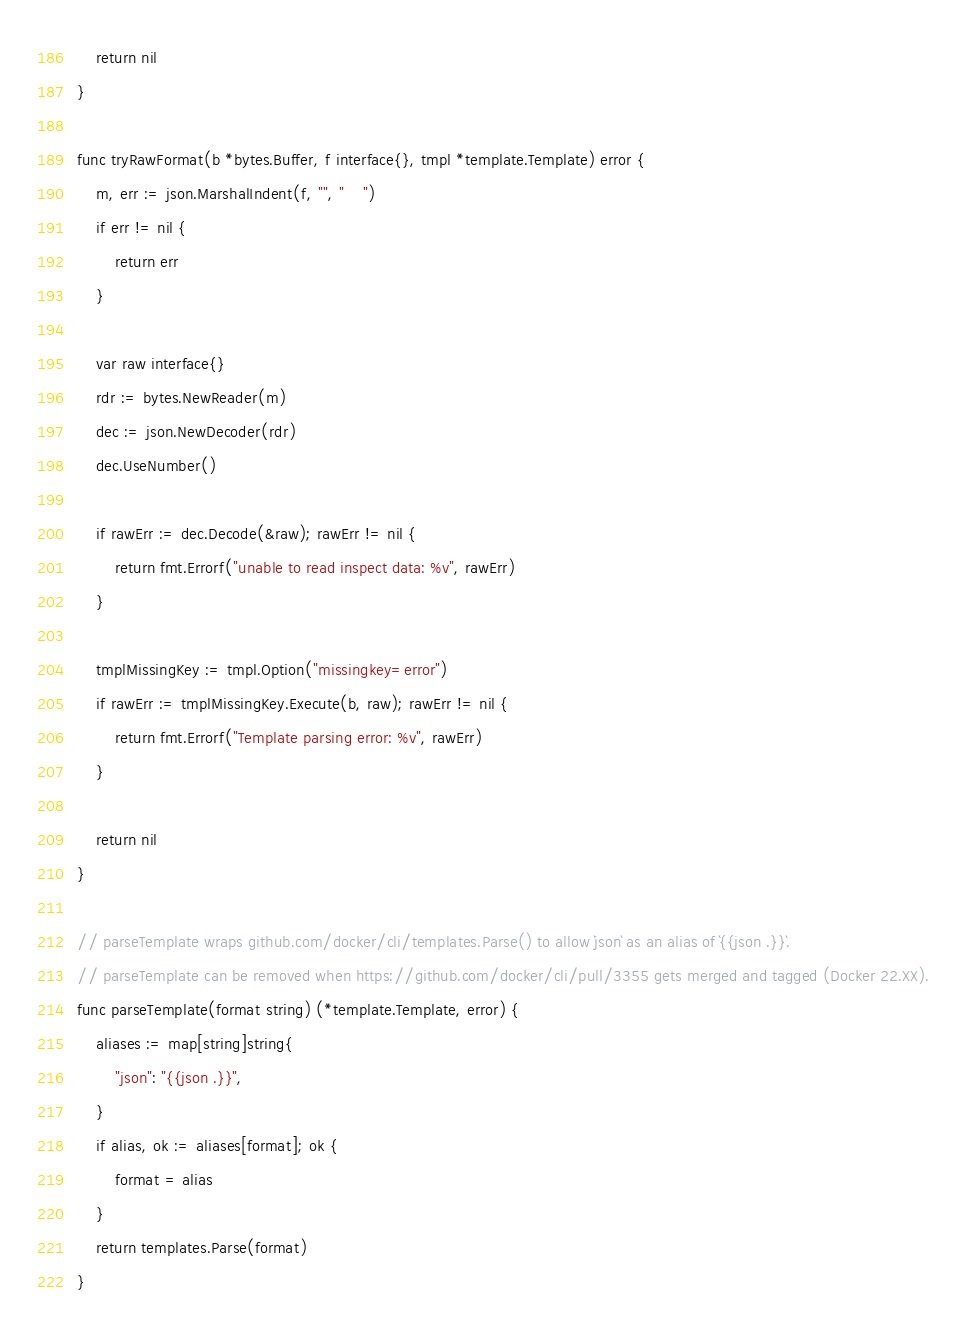Convert code to text. <code><loc_0><loc_0><loc_500><loc_500><_Go_>	return nil
}

func tryRawFormat(b *bytes.Buffer, f interface{}, tmpl *template.Template) error {
	m, err := json.MarshalIndent(f, "", "    ")
	if err != nil {
		return err
	}

	var raw interface{}
	rdr := bytes.NewReader(m)
	dec := json.NewDecoder(rdr)
	dec.UseNumber()

	if rawErr := dec.Decode(&raw); rawErr != nil {
		return fmt.Errorf("unable to read inspect data: %v", rawErr)
	}

	tmplMissingKey := tmpl.Option("missingkey=error")
	if rawErr := tmplMissingKey.Execute(b, raw); rawErr != nil {
		return fmt.Errorf("Template parsing error: %v", rawErr)
	}

	return nil
}

// parseTemplate wraps github.com/docker/cli/templates.Parse() to allow `json` as an alias of `{{json .}}`.
// parseTemplate can be removed when https://github.com/docker/cli/pull/3355 gets merged and tagged (Docker 22.XX).
func parseTemplate(format string) (*template.Template, error) {
	aliases := map[string]string{
		"json": "{{json .}}",
	}
	if alias, ok := aliases[format]; ok {
		format = alias
	}
	return templates.Parse(format)
}
</code> 